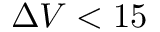Convert formula to latex. <formula><loc_0><loc_0><loc_500><loc_500>\Delta V < 1 5</formula> 